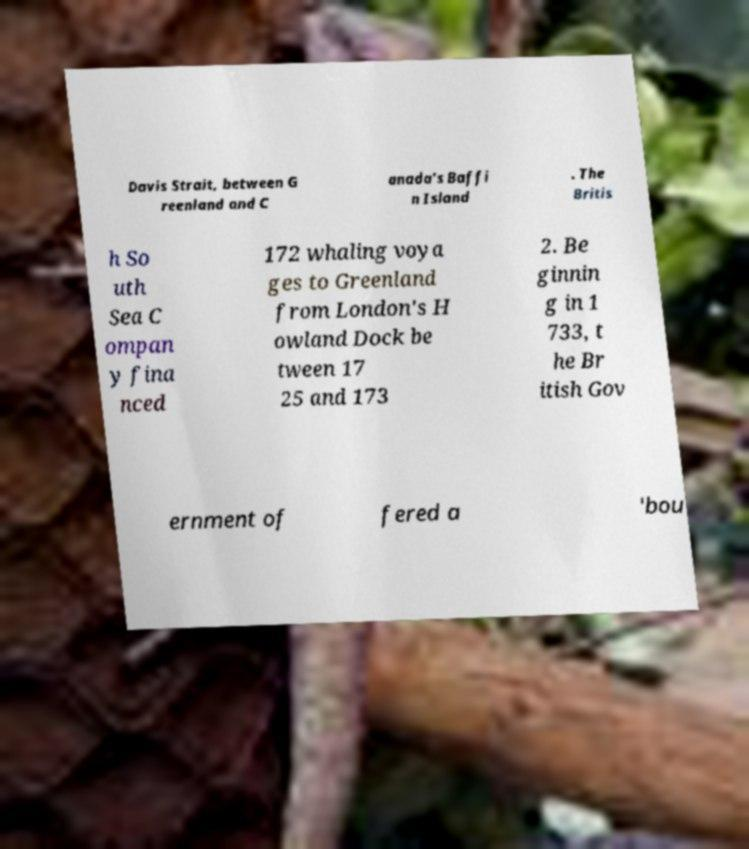Can you read and provide the text displayed in the image?This photo seems to have some interesting text. Can you extract and type it out for me? Davis Strait, between G reenland and C anada's Baffi n Island . The Britis h So uth Sea C ompan y fina nced 172 whaling voya ges to Greenland from London's H owland Dock be tween 17 25 and 173 2. Be ginnin g in 1 733, t he Br itish Gov ernment of fered a 'bou 